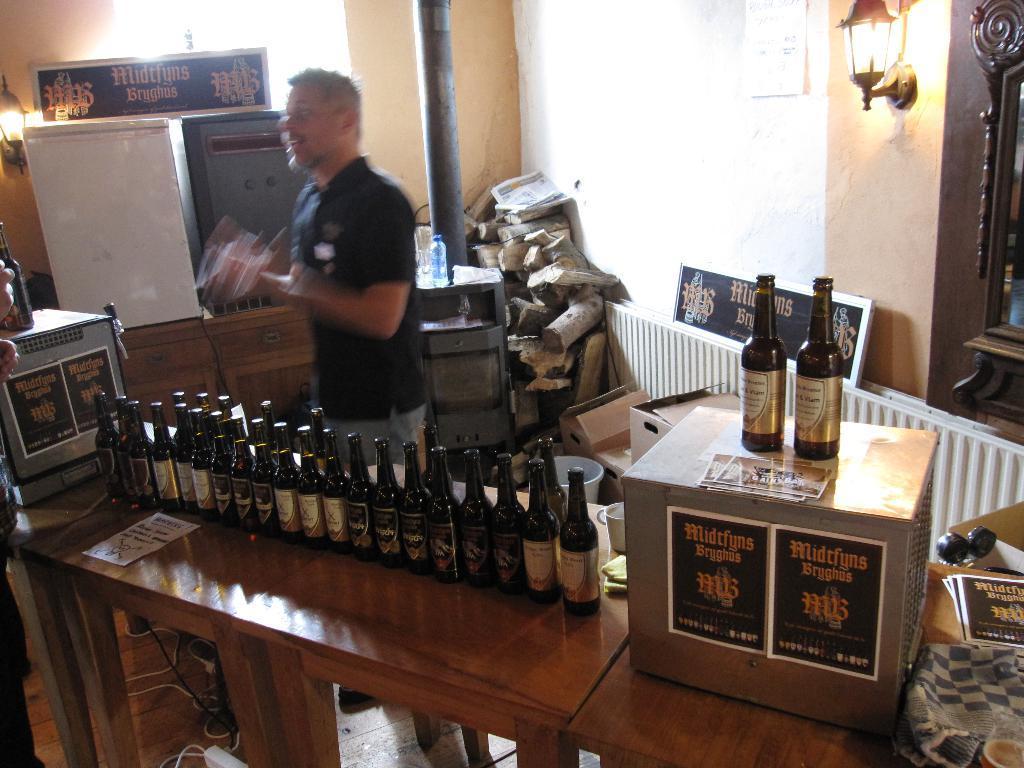Describe this image in one or two sentences. In this image I see a man and in front of him there is a table and there are lot of bottles and boxes on it. In the background I see the wall, light and few things over here. 